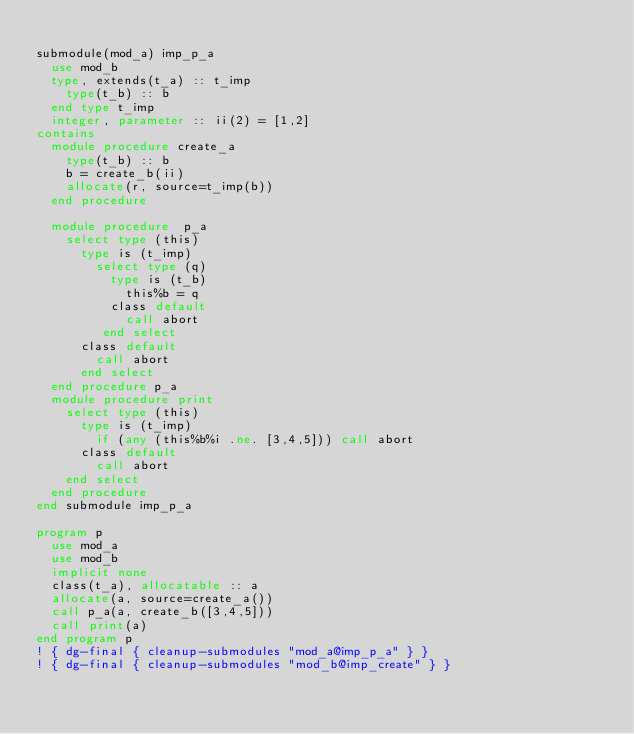Convert code to text. <code><loc_0><loc_0><loc_500><loc_500><_FORTRAN_>
submodule(mod_a) imp_p_a
  use mod_b
  type, extends(t_a) :: t_imp
    type(t_b) :: b
  end type t_imp
  integer, parameter :: ii(2) = [1,2]
contains
  module procedure create_a
    type(t_b) :: b
    b = create_b(ii)
    allocate(r, source=t_imp(b))
  end procedure

  module procedure  p_a
    select type (this)
      type is (t_imp)
        select type (q)
          type is (t_b)
            this%b = q
          class default
            call abort
         end select
      class default
        call abort
      end select
  end procedure p_a
  module procedure print
    select type (this)
      type is (t_imp)
        if (any (this%b%i .ne. [3,4,5])) call abort
      class default
        call abort
    end select
  end procedure
end submodule imp_p_a

program p
  use mod_a
  use mod_b
  implicit none
  class(t_a), allocatable :: a
  allocate(a, source=create_a())
  call p_a(a, create_b([3,4,5]))
  call print(a)
end program p
! { dg-final { cleanup-submodules "mod_a@imp_p_a" } }
! { dg-final { cleanup-submodules "mod_b@imp_create" } }

</code> 